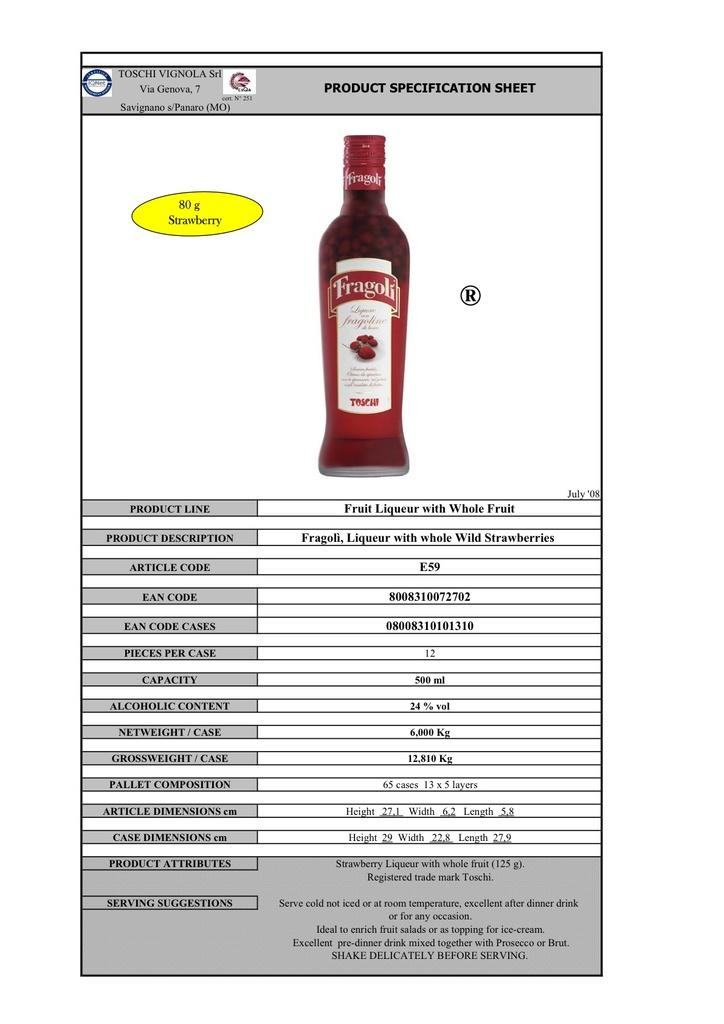<image>
Render a clear and concise summary of the photo. A picture of Fragoli fruit liqueur on a product information sheet. 